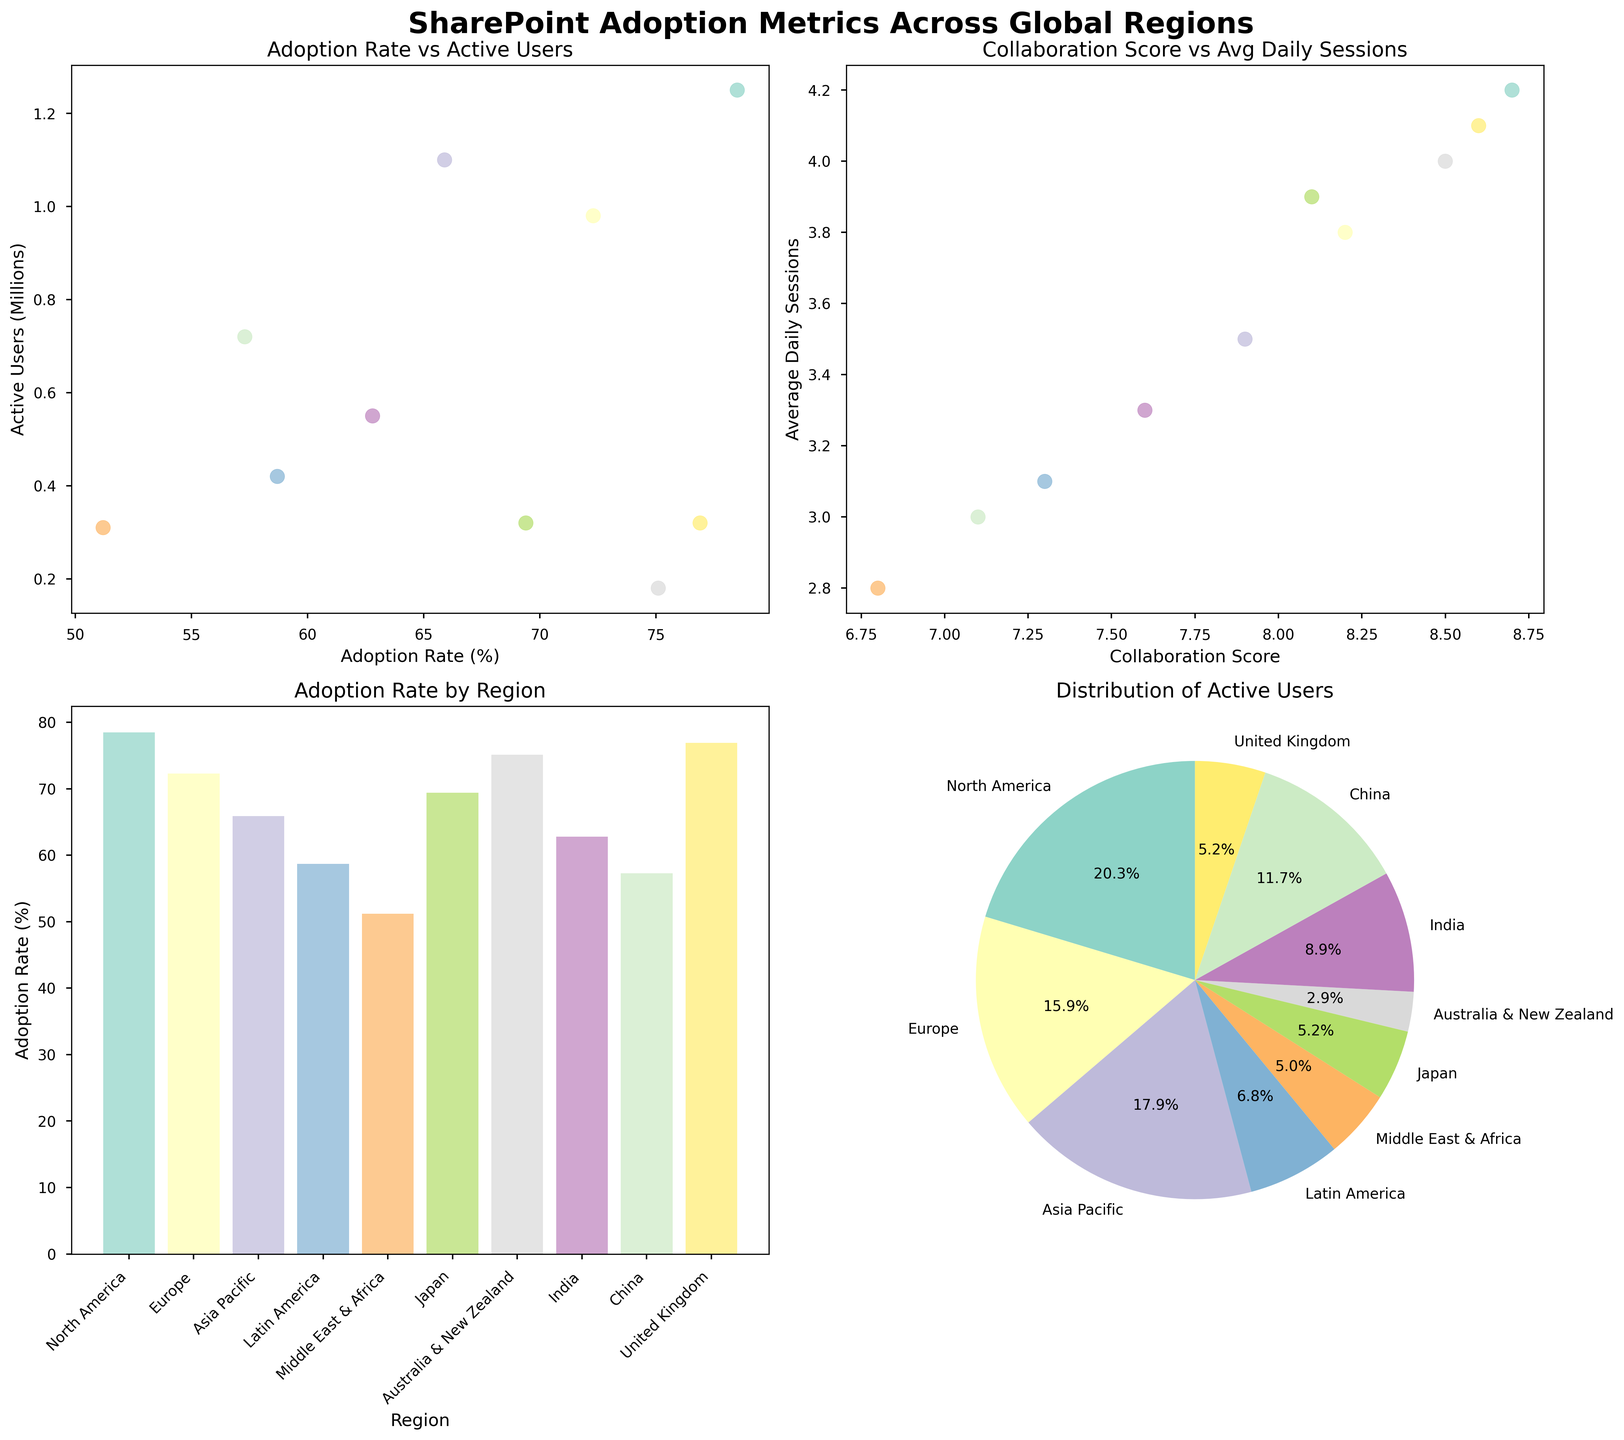What is the adoption rate in North America? By looking at the Adoption Rate by Region bar chart, identify the bar corresponding to North America and read its height along the y-axis.
Answer: 78.5% Which region has the least number of active users? In the Active Users Pie Chart, identify the slice with the smallest percentage and check its label to determine the corresponding region.
Answer: Australia & New Zealand How many regions have an average daily session count of 4.0 or higher? Look at the hollow markers in the Collaboration Score vs Avg Daily Sessions scatter plot. Count every region with a y-value of 4.0 or greater.
Answer: 4 Which region has the highest collaboration score? In the Collaboration Score vs Avg Daily Sessions scatter plot, locate the point with the highest x-value along the Collaboration Score axis and read the corresponding region.
Answer: North America Which region shows the closest adoption rate to 70%? Examine the adoption rates in the Adoption Rate by Region bar chart and identify the bar whose height is closest to 70%.
Answer: Japan What is the difference in adoption rates between North America and the Middle East & Africa? Identify the height of the North America and Middle East & Africa bars in the Adoption Rate by Region bar chart and subtract to find the difference.
Answer: 27.3% Which region has the most significant discrepancy between its average daily sessions and collaboration score? By examining the Collaboration Score vs Avg Daily Sessions scatter plot, identify the point with the highest difference when comparing its x and y-values from the same marker.
Answer: North America Is there a region with more than 4 million active users? Looking at the Active Users Pie Chart, no slice seems exceptionally large, indicating none have such a high number.
Answer: No Do regions with higher collaboration scores also tend to have higher average daily sessions? Check if the points in the Collaboration Score vs Avg Daily Sessions scatter plot trend upwards as you move to the right (higher collaboration scores).
Answer: Generally, yes What are the three regions with the highest adoption rates? By examining the top three tallest bars in the Adoption Rate by Region bar chart, identify their labels.
Answer: North America, United Kingdom, and Australia & New Zealand 